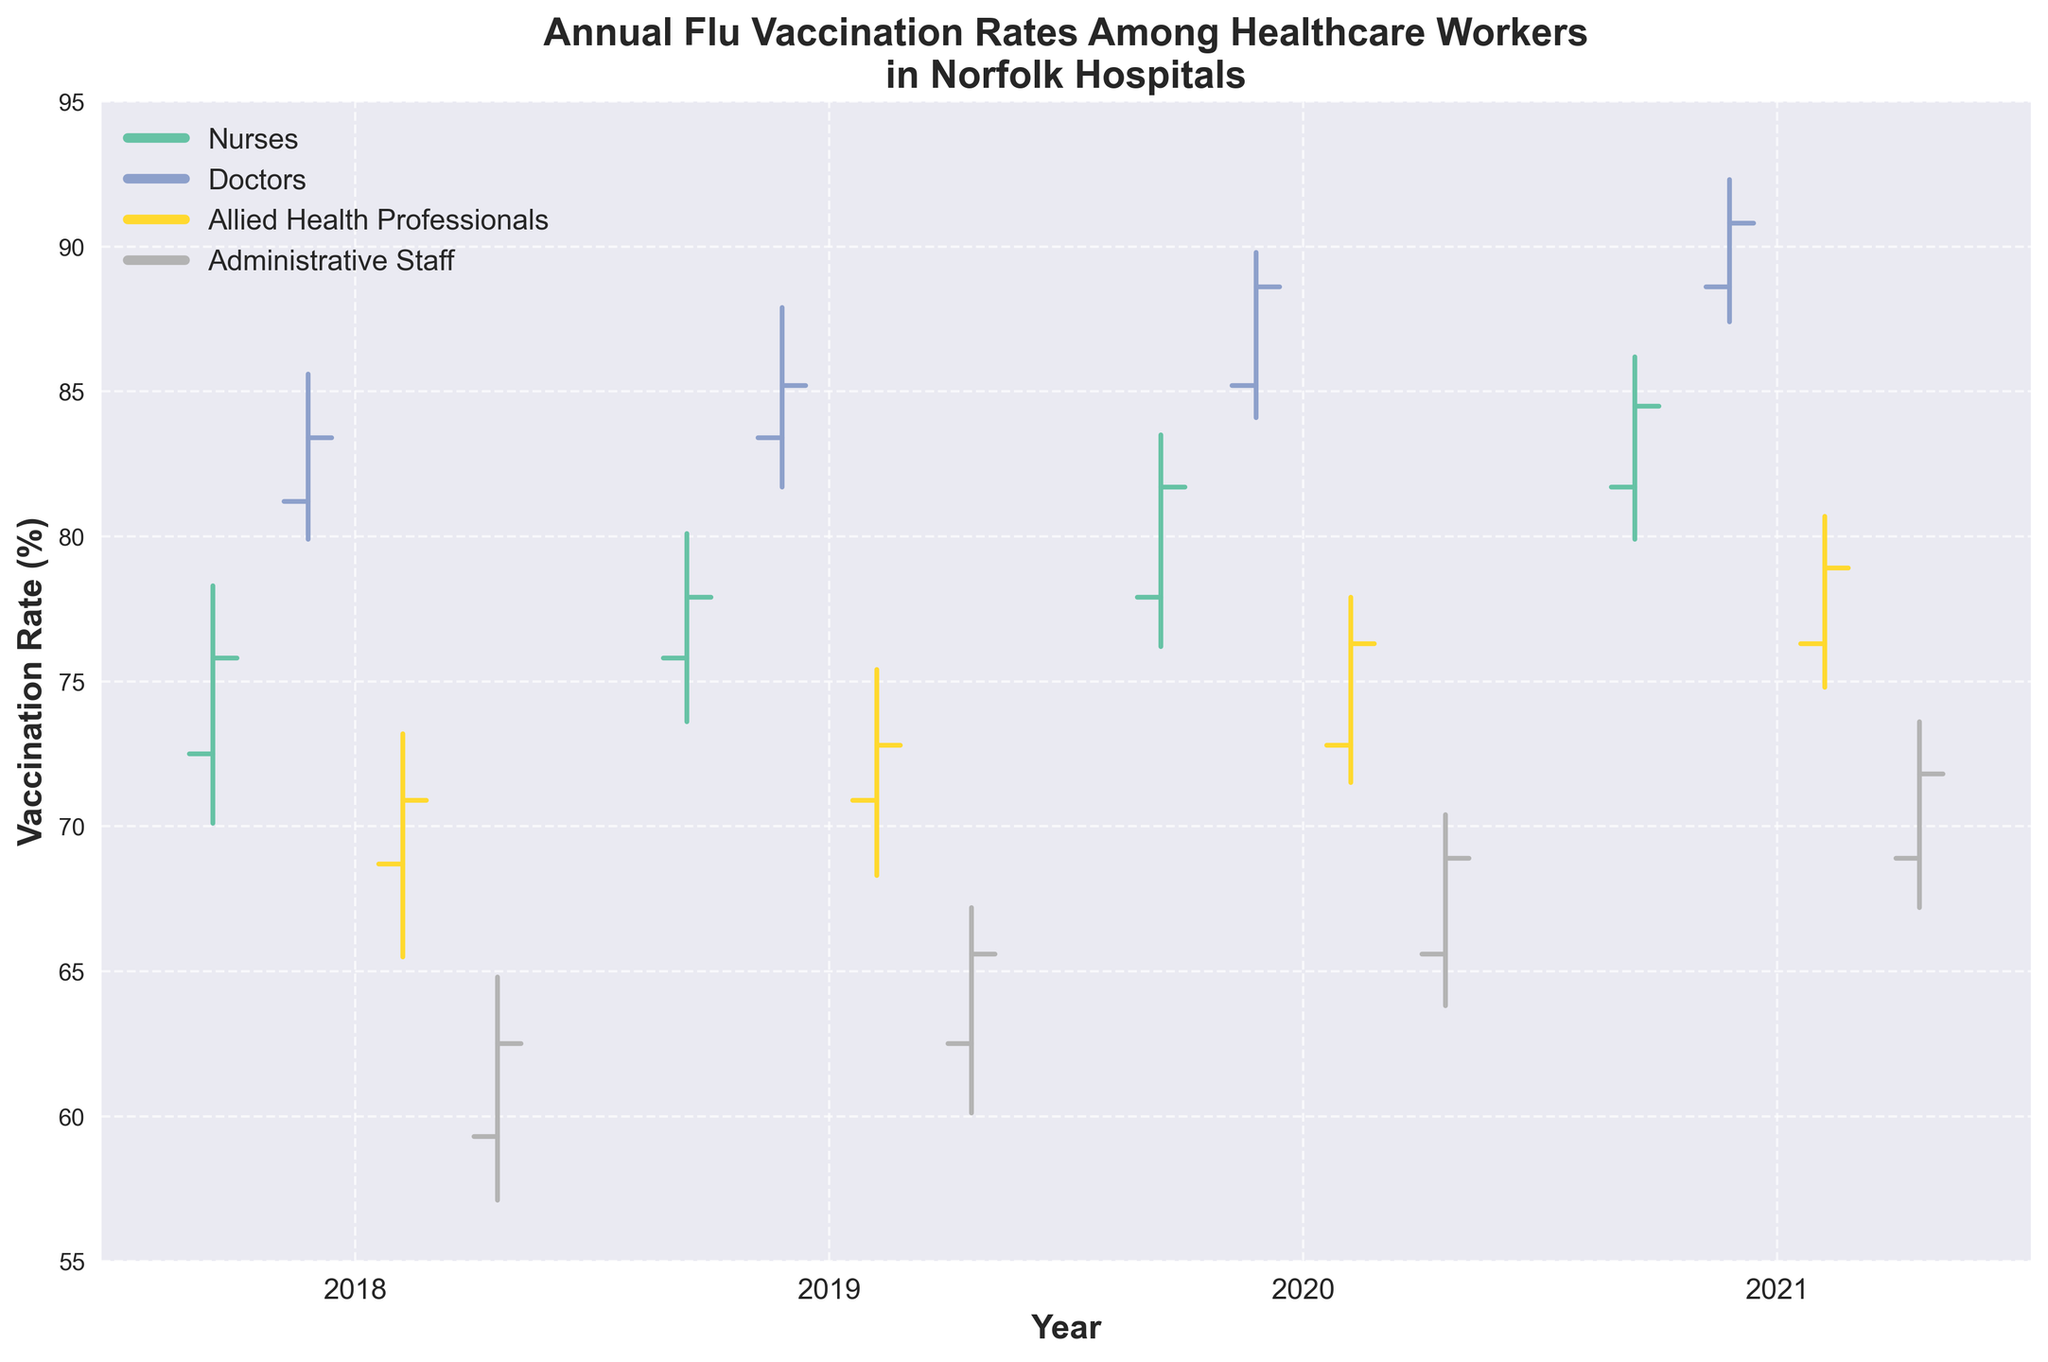What is the title of the chart? The title is typically placed at the top of the chart. In this case, it reads "Annual Flu Vaccination Rates Among Healthcare Workers in Norfolk Hospitals."
Answer: Annual Flu Vaccination Rates Among Healthcare Workers in Norfolk Hospitals What is the highest flu vaccination rate recorded for doctors? The highest flu vaccination rate for doctors can be found by looking at the highest point in the OHLC bars for the 'Doctors' role. The highest value is 92.3% in 2021.
Answer: 92.3% Between 2018 and 2021, in which year did nurses have the highest closing flu vaccination rate? The closing rate is marked at the end of each year for the 'Nurses' role. In 2021, the closing rate for nurses was the highest at 84.5%.
Answer: 2021 Which job role saw the highest increase in closing rates from 2018 to 2021? To determine the highest increase, compare the closing rates of 2018 and 2021 for each job role: Nurses (75.8 to 84.5), Doctors (83.4 to 90.8), Allied Health Professionals (70.9 to 78.9), and Administrative Staff (62.5 to 71.8). The nurses had the largest increase.
Answer: Nurses What was the lowest annual vaccination rate for administrative staff over the given years? The lowest rate is the minimum low value across all years for administrative staff. The lowest value is 57.1% in 2018.
Answer: 57.1% Did the allied health professionals' flu vaccination rates ever drop below 70% after 2018? After 2018, check the low values for Allied Health Professionals in years 2019, 2020, and 2021. The lowest value post-2018 is 68.3% in 2019, which is indeed below 70%.
Answer: Yes By how much did the vaccination rate for doctors increase from the open rate in 2018 to the close rate in 2021? Compare the open rate of doctors in 2018 (81.2%) with the close rate in 2021 (90.8%). The increase is 90.8 - 81.2 = 9.6%.
Answer: 9.6% Which year shows the smallest fluctuation in vaccination rates for Allied Health Professionals? Fluctuation can be determined by the difference between the high and low values for each year. Calculate: 2018 (73.2 - 65.5 = 7.7), 2019 (75.4 - 68.3 = 7.1), 2020 (77.9 - 71.5 = 6.4), and 2021 (80.7 - 74.8 = 5.9). The smallest fluctuation is in 2021.
Answer: 2021 How did the vaccination rates for nurses compare between 2018 and 2021 in terms of their closing rates? Compare the closing rates of nurses in 2018 (75.8%) and 2021 (84.5%). The closing rate increased by 84.5 - 75.8 = 8.7%.
Answer: Increased by 8.7% What trend can we observe about the flu vaccination rates of administrative staff from 2018 to 2021? Observing the closing rates for administrative staff: 2018 (62.5%), 2019 (65.6%), 2020 (68.9%), and 2021 (71.8%), there is a consistent upward trend.
Answer: Consistent upward trend 